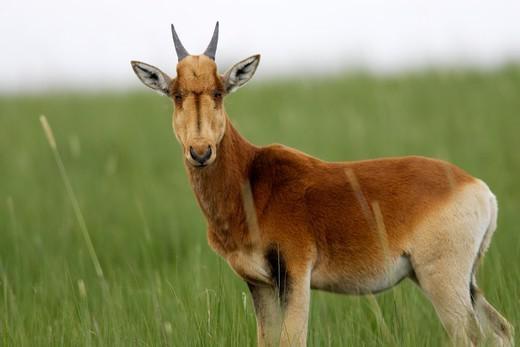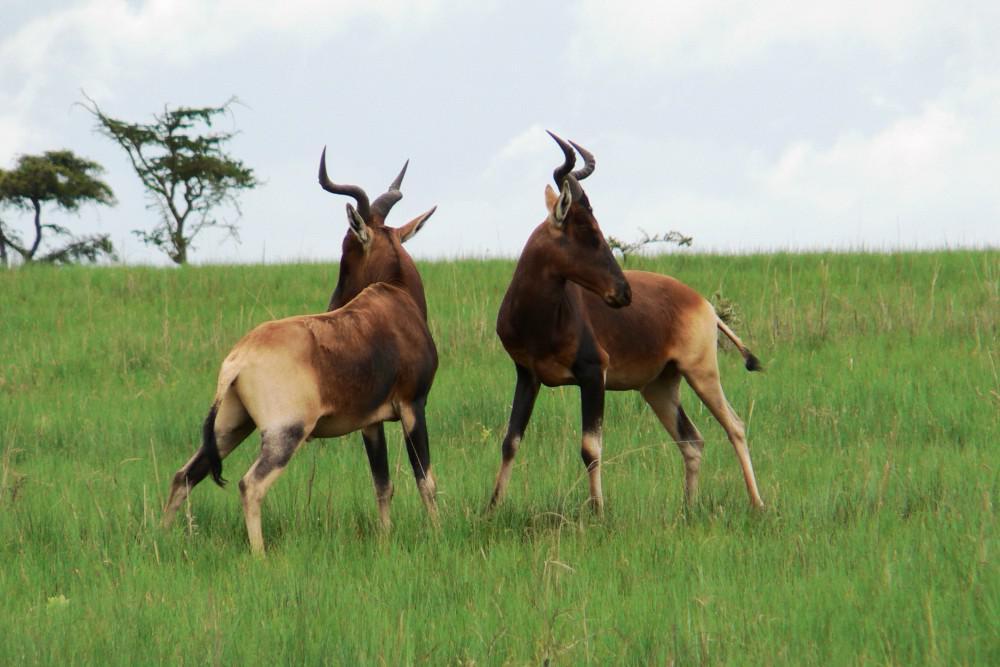The first image is the image on the left, the second image is the image on the right. Assess this claim about the two images: "there are no more than three animals in the image on the right". Correct or not? Answer yes or no. Yes. 